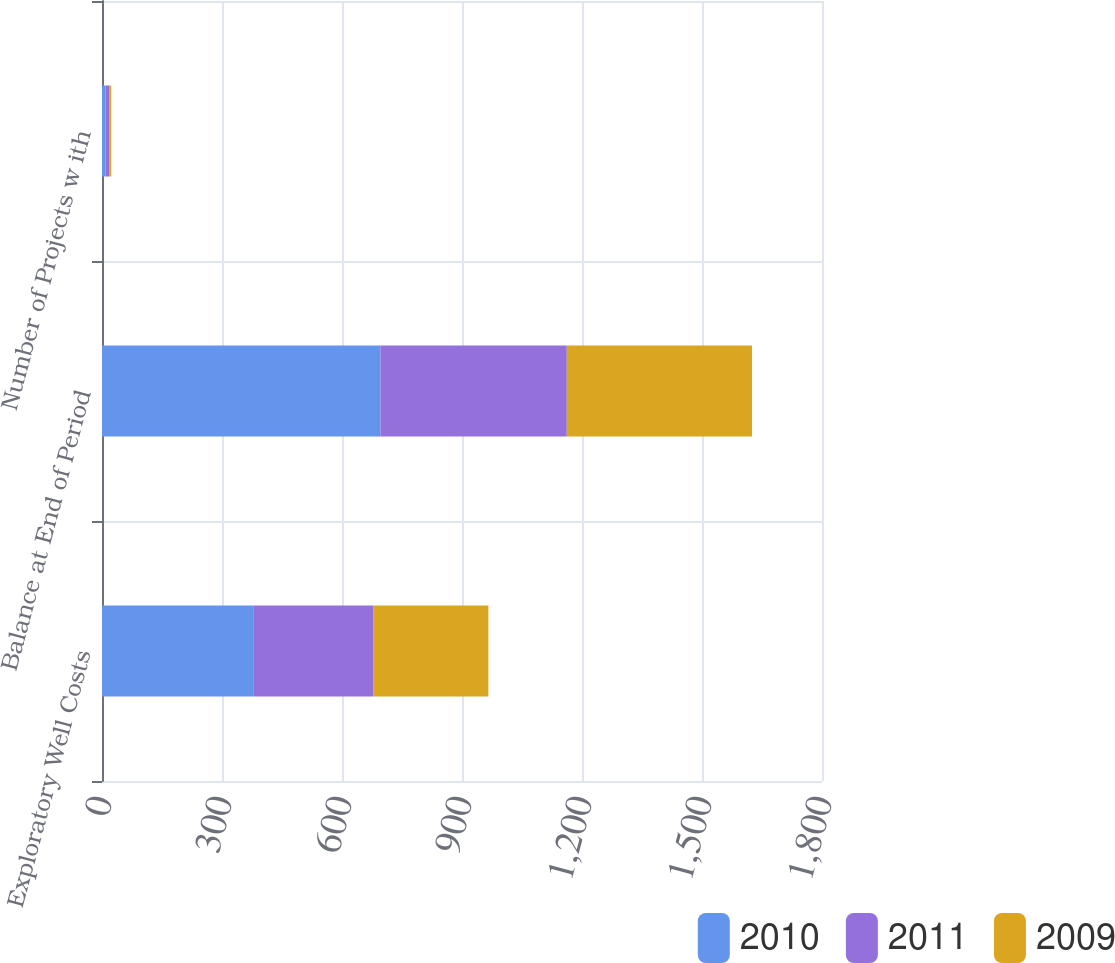Convert chart. <chart><loc_0><loc_0><loc_500><loc_500><stacked_bar_chart><ecel><fcel>Exploratory Well Costs<fcel>Balance at End of Period<fcel>Number of Projects w ith<nl><fcel>2010<fcel>378<fcel>696<fcel>9<nl><fcel>2011<fcel>300<fcel>466<fcel>9<nl><fcel>2009<fcel>288<fcel>463<fcel>5<nl></chart> 